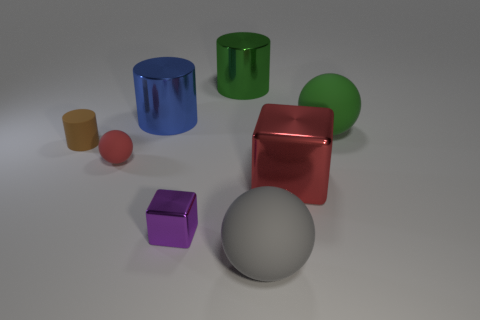Subtract all tiny brown cylinders. How many cylinders are left? 2 Subtract all blue balls. Subtract all blue blocks. How many balls are left? 3 Subtract all gray balls. How many red blocks are left? 1 Subtract all purple objects. Subtract all small metallic cubes. How many objects are left? 6 Add 2 cubes. How many cubes are left? 4 Add 2 large gray matte balls. How many large gray matte balls exist? 3 Add 1 large green balls. How many objects exist? 9 Subtract all blue cylinders. How many cylinders are left? 2 Subtract 0 purple spheres. How many objects are left? 8 Subtract all cubes. How many objects are left? 6 